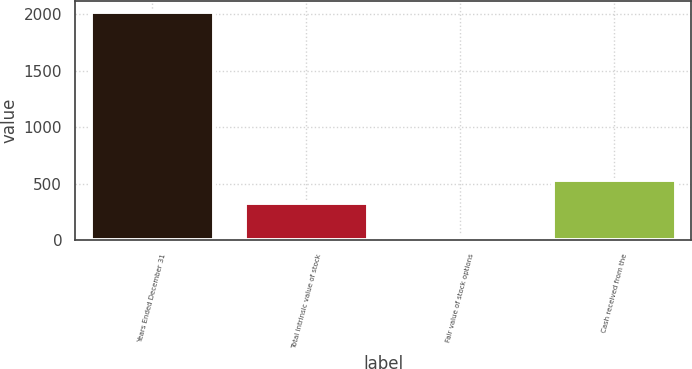Convert chart to OTSL. <chart><loc_0><loc_0><loc_500><loc_500><bar_chart><fcel>Years Ended December 31<fcel>Total intrinsic value of stock<fcel>Fair value of stock options<fcel>Cash received from the<nl><fcel>2015<fcel>332<fcel>30<fcel>530.5<nl></chart> 